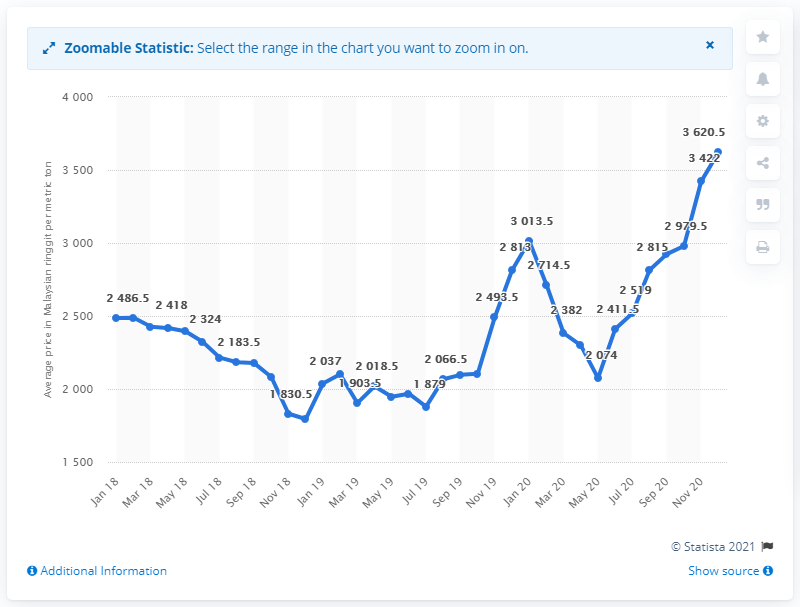Indicate a few pertinent items in this graphic. In December 2020, the average monthly price for crude palm oil in Malaysia was approximately 3,620.5 Malaysian ringgit per metric tonne. 